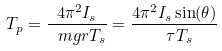Convert formula to latex. <formula><loc_0><loc_0><loc_500><loc_500>T _ { p } = { \frac { 4 \pi ^ { 2 } I _ { s } } { \ m g r T _ { s } } } = { \frac { 4 \pi ^ { 2 } I _ { s } \sin ( \theta ) } { \ \tau T _ { s } } }</formula> 